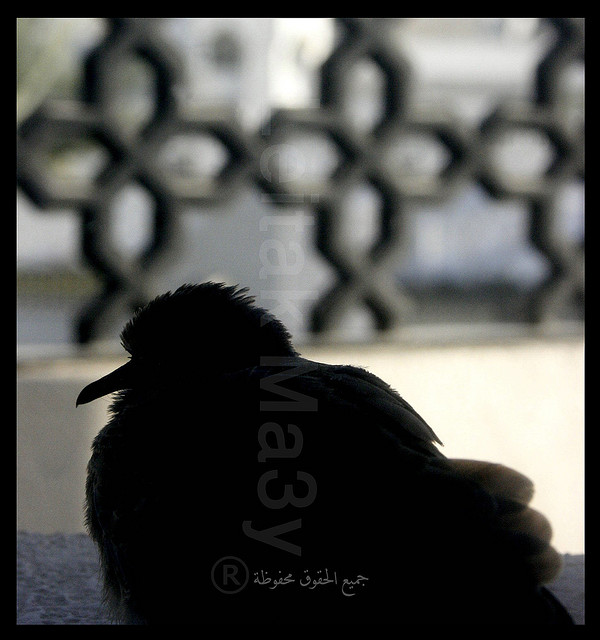<image>What textile do these animals play a part in producing? It is ambiguous what textile these animals play a part in producing. It could be wool, feather, cloth or down. What kind of bird is this? I am not sure what kind of bird this is. It could be a sparrow, gull, pigeon, robin, or crow. What textile do these animals play a part in producing? It is ambiguous what textile do these animals play a part in producing. It can be wool, feather, down or cloth. What kind of bird is this? I don't know what kind of bird this is. It could be a sparrow, gull, pigeon, robin, black crow, or something else. 